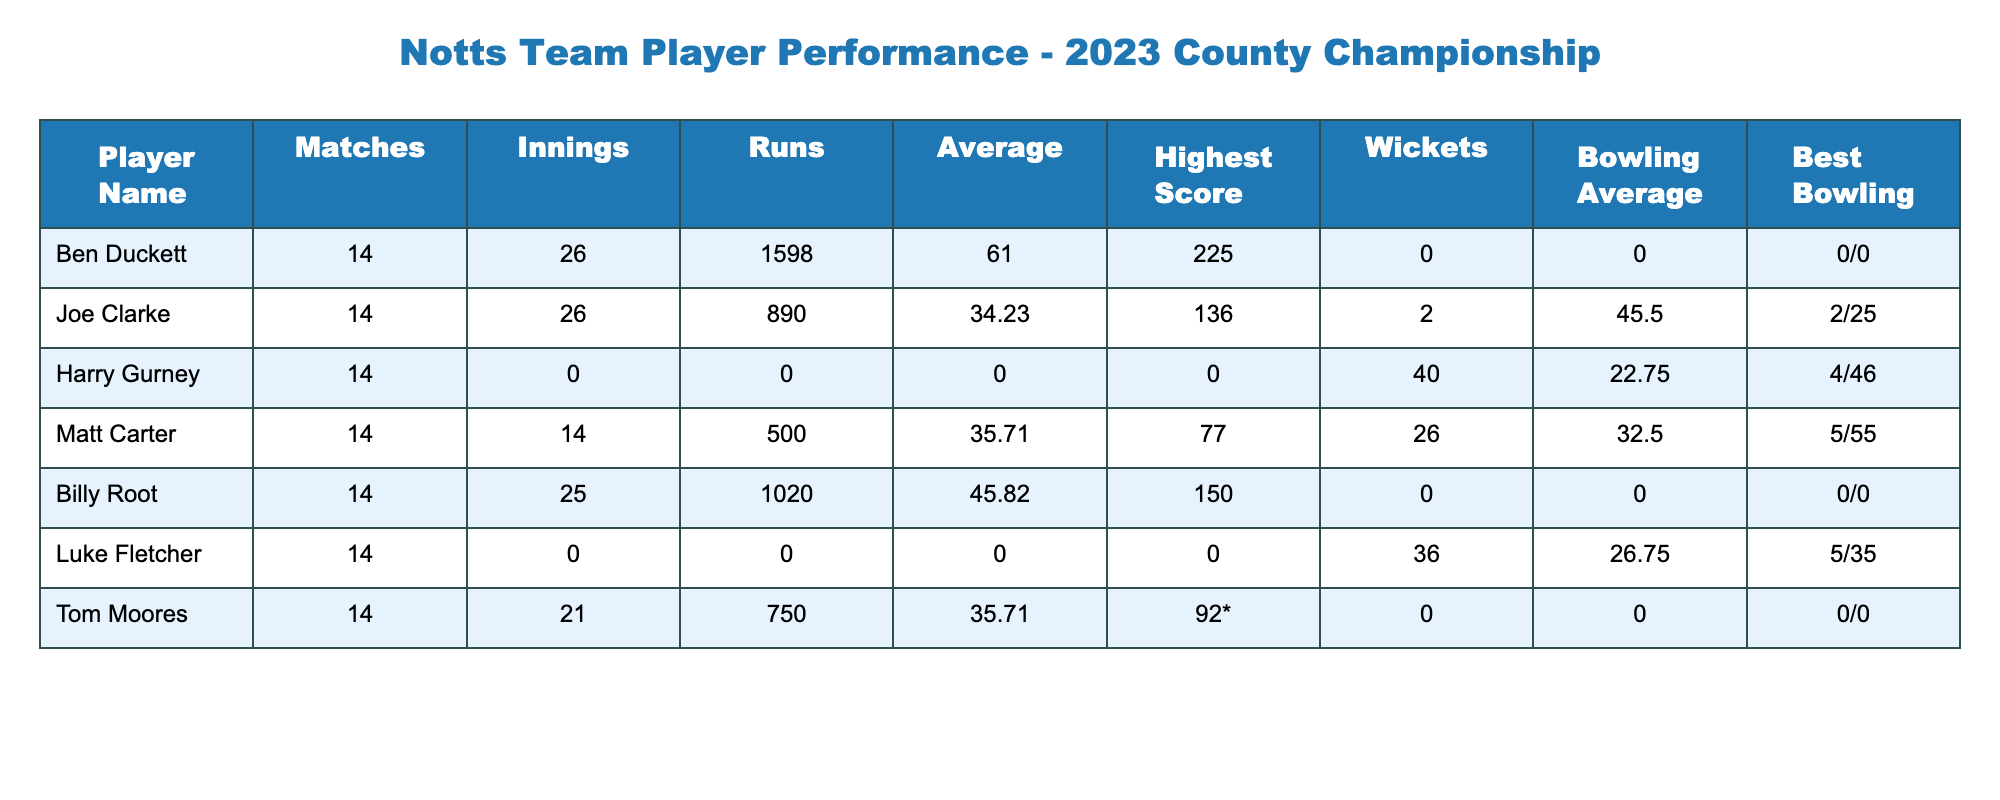What is Ben Duckett's highest score in the 2023 County Championship? The table shows Ben Duckett's highest score as 225, which is listed under the "Highest Score" column.
Answer: 225 How many wickets did Matt Carter take during the season? According to the table, Matt Carter took 26 wickets, which can be found in the "Wickets" column.
Answer: 26 What is the average runs scored by Joe Clarke? Joe Clarke's average runs scored is listed as 34.23 under the "Average" column.
Answer: 34.23 Who had the best bowling average among the players listed? Looking at the "Bowling Average" column, Harry Gurney had the best bowling average of 22.75.
Answer: Harry Gurney What is the total number of runs scored by Notts players in the table? To find the total, we sum up the runs: 1598 (Duckett) + 890 (Clarke) + 0 (Gurney) + 500 (Carter) + 1020 (Root) + 0 (Fletcher) + 750 (Moores) = 3968. Therefore, the total runs scored by players is 3968.
Answer: 3968 Did any player achieve a five-wicket haul in the season? The table indicates that Luke Fletcher achieved the best bowling figures of 5/35, which is confirmed in the "Best Bowling" column, showing that he took five wickets in that innings.
Answer: Yes What is the combined number of wickets taken by Duckett and Clarke? Both Ben Duckett and Joe Clarke took 0 and 2 wickets respectively. Adding them together gives 0 + 2 = 2 wickets.
Answer: 2 Which player had the highest batting average, and what was it? By checking the "Average" column, Ben Duckett had the highest average at 61.00, confirming that he performed the best statistically.
Answer: Ben Duckett, 61.00 What percentage of matches did Tom Moores play as an innings? Tom Moores played 21 innings out of 14 matches, so his percentage is (21/14) * 100 = 150%. This indicates he played multiple innings in some matches.
Answer: 150% 